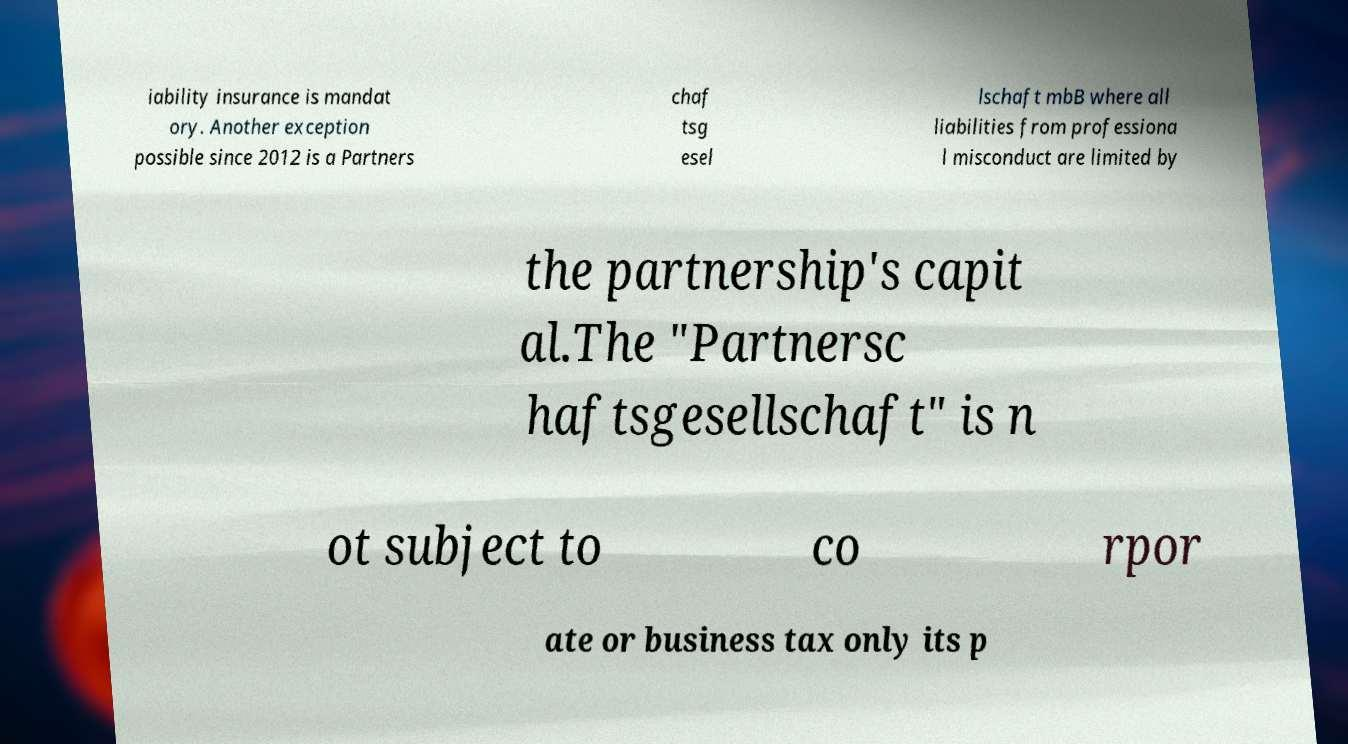Can you accurately transcribe the text from the provided image for me? iability insurance is mandat ory. Another exception possible since 2012 is a Partners chaf tsg esel lschaft mbB where all liabilities from professiona l misconduct are limited by the partnership's capit al.The "Partnersc haftsgesellschaft" is n ot subject to co rpor ate or business tax only its p 